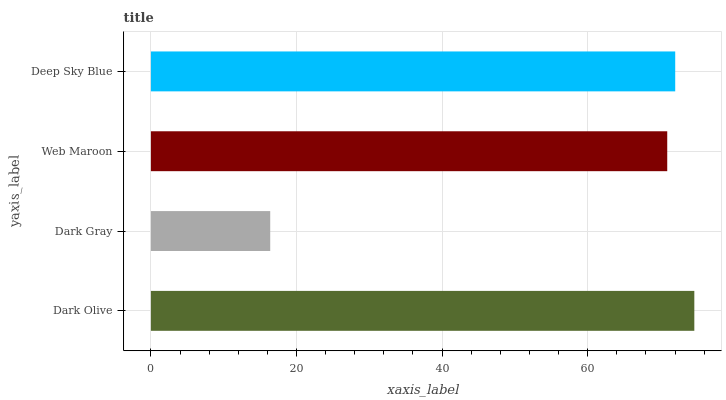Is Dark Gray the minimum?
Answer yes or no. Yes. Is Dark Olive the maximum?
Answer yes or no. Yes. Is Web Maroon the minimum?
Answer yes or no. No. Is Web Maroon the maximum?
Answer yes or no. No. Is Web Maroon greater than Dark Gray?
Answer yes or no. Yes. Is Dark Gray less than Web Maroon?
Answer yes or no. Yes. Is Dark Gray greater than Web Maroon?
Answer yes or no. No. Is Web Maroon less than Dark Gray?
Answer yes or no. No. Is Deep Sky Blue the high median?
Answer yes or no. Yes. Is Web Maroon the low median?
Answer yes or no. Yes. Is Dark Gray the high median?
Answer yes or no. No. Is Dark Gray the low median?
Answer yes or no. No. 